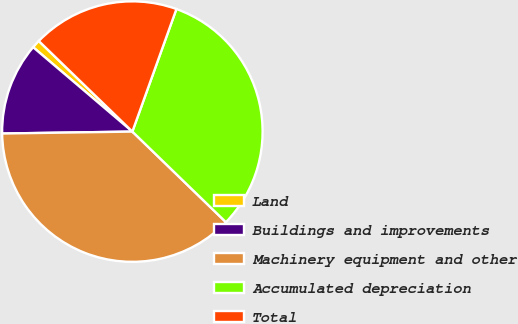Convert chart to OTSL. <chart><loc_0><loc_0><loc_500><loc_500><pie_chart><fcel>Land<fcel>Buildings and improvements<fcel>Machinery equipment and other<fcel>Accumulated depreciation<fcel>Total<nl><fcel>1.03%<fcel>11.45%<fcel>37.52%<fcel>31.75%<fcel>18.25%<nl></chart> 